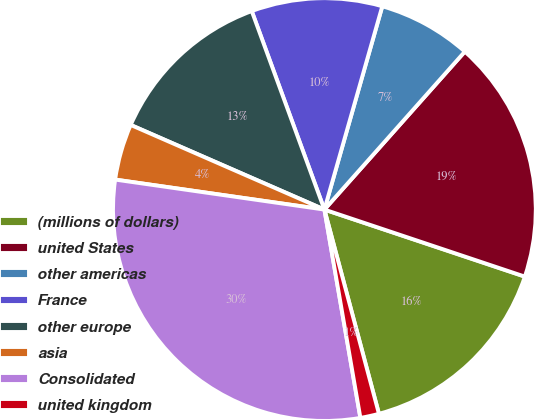<chart> <loc_0><loc_0><loc_500><loc_500><pie_chart><fcel>(millions of dollars)<fcel>united States<fcel>other americas<fcel>France<fcel>other europe<fcel>asia<fcel>Consolidated<fcel>united kingdom<nl><fcel>15.71%<fcel>18.57%<fcel>7.15%<fcel>10.0%<fcel>12.86%<fcel>4.29%<fcel>29.99%<fcel>1.43%<nl></chart> 